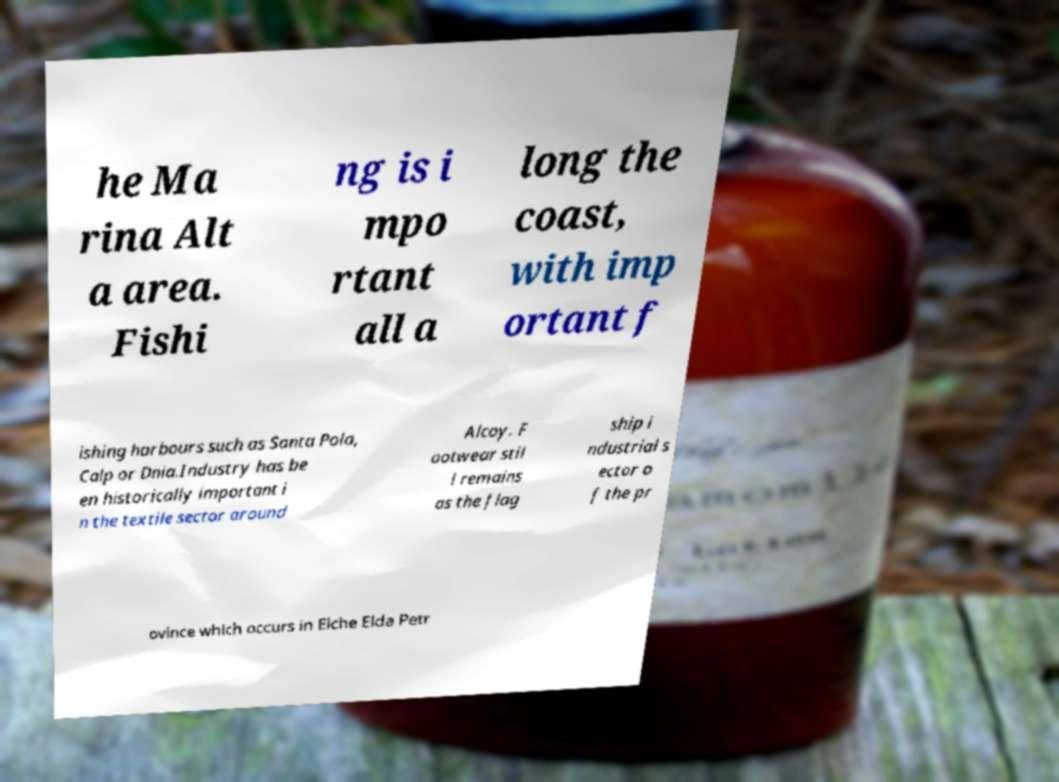Please read and relay the text visible in this image. What does it say? he Ma rina Alt a area. Fishi ng is i mpo rtant all a long the coast, with imp ortant f ishing harbours such as Santa Pola, Calp or Dnia.Industry has be en historically important i n the textile sector around Alcoy. F ootwear stil l remains as the flag ship i ndustrial s ector o f the pr ovince which occurs in Elche Elda Petr 